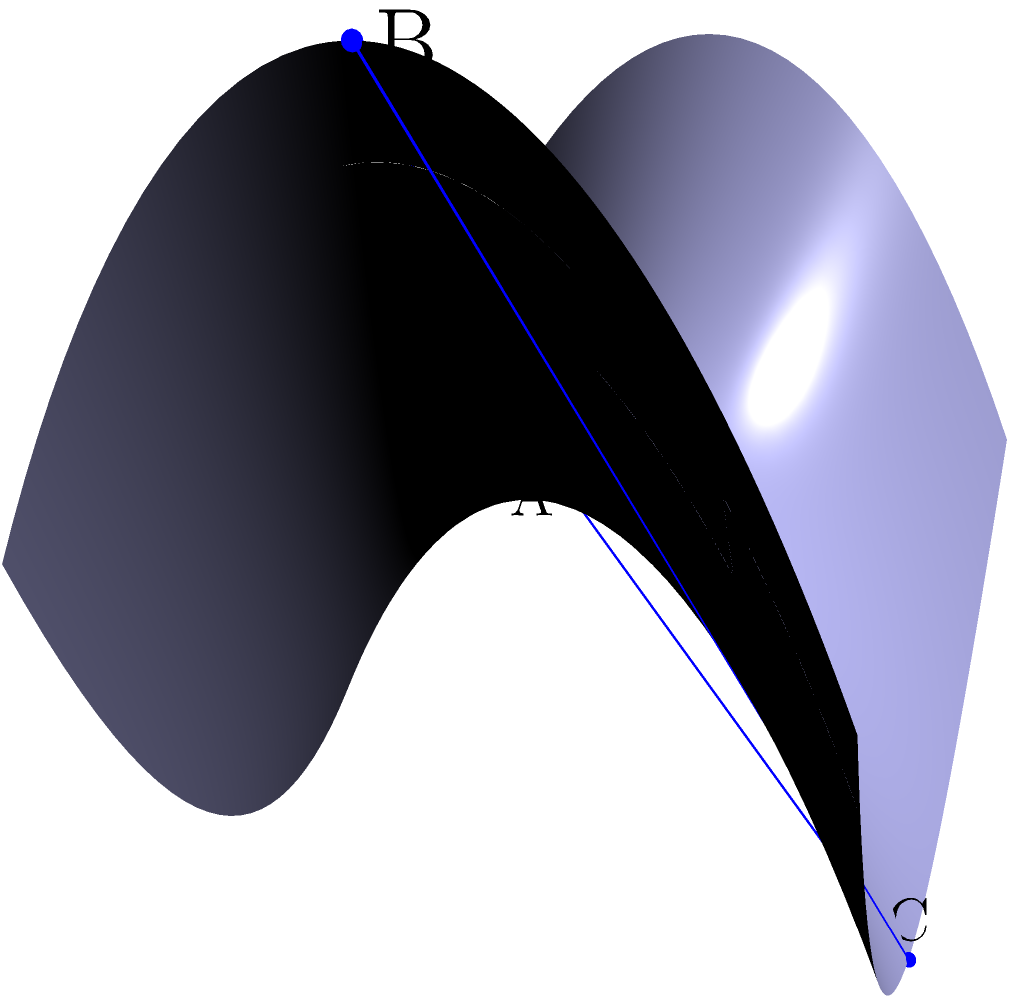Yo, lyrical genius! Imagine you're spittin' rhymes on a stage shaped like a hyperbolic paraboloid (saddle surface). There's a triangular spotlight with vertices at A(0,0,0), B(1,0,1), and C(0,1,-1). What's the area of this triangle on this non-Euclidean surface? Use the formula $A = \sqrt{s(s-a)(s-b)(s-c)}$, where $s$ is the semi-perimeter, and $a$, $b$, and $c$ are the geodesic distances between the vertices. Let's break it down, bar by bar:

1) First, we need to calculate the geodesic distances between the vertices. On a hyperbolic paraboloid, these aren't straight lines, but curves.

2) The geodesic distance formula for a hyperbolic paraboloid is complex, but for small triangles, we can approximate it with the Euclidean distance:

   $d = \sqrt{(x_2-x_1)^2 + (y_2-y_1)^2 + (z_2-z_1)^2}$

3) Let's calculate each side:
   
   $a = \sqrt{(1-0)^2 + (0-0)^2 + (1-0)^2} = \sqrt{2}$
   $b = \sqrt{(0-1)^2 + (1-0)^2 + (-1-1)^2} = \sqrt{6}$
   $c = \sqrt{(0-0)^2 + (1-0)^2 + (-1-0)^2} = \sqrt{2}$

4) Now, calculate the semi-perimeter:

   $s = \frac{a+b+c}{2} = \frac{\sqrt{2}+\sqrt{6}+\sqrt{2}}{2} = \frac{\sqrt{2}+\sqrt{6}}{2}$

5) Plug everything into Heron's formula:

   $A = \sqrt{s(s-a)(s-b)(s-c)}$

   $= \sqrt{\frac{\sqrt{2}+\sqrt{6}}{2}(\frac{\sqrt{2}+\sqrt{6}}{2}-\sqrt{2})(\frac{\sqrt{2}+\sqrt{6}}{2}-\sqrt{6})(\frac{\sqrt{2}+\sqrt{6}}{2}-\sqrt{2})}$

6) Simplify (this is a complex step, so we'll skip the details):

   $A = \frac{\sqrt{3}}{2}$

This area is smaller than it would be on a flat surface due to the curvature of the hyperbolic paraboloid.
Answer: $\frac{\sqrt{3}}{2}$ 